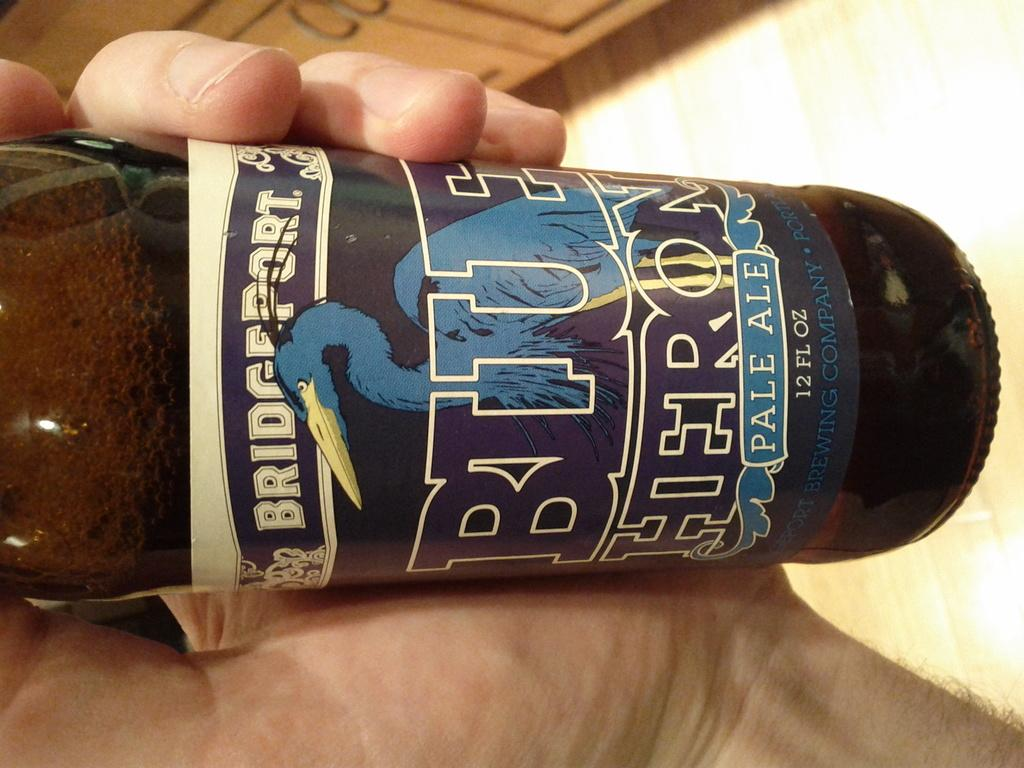<image>
Write a terse but informative summary of the picture. A hand holding a full bottle of Pale Ale 